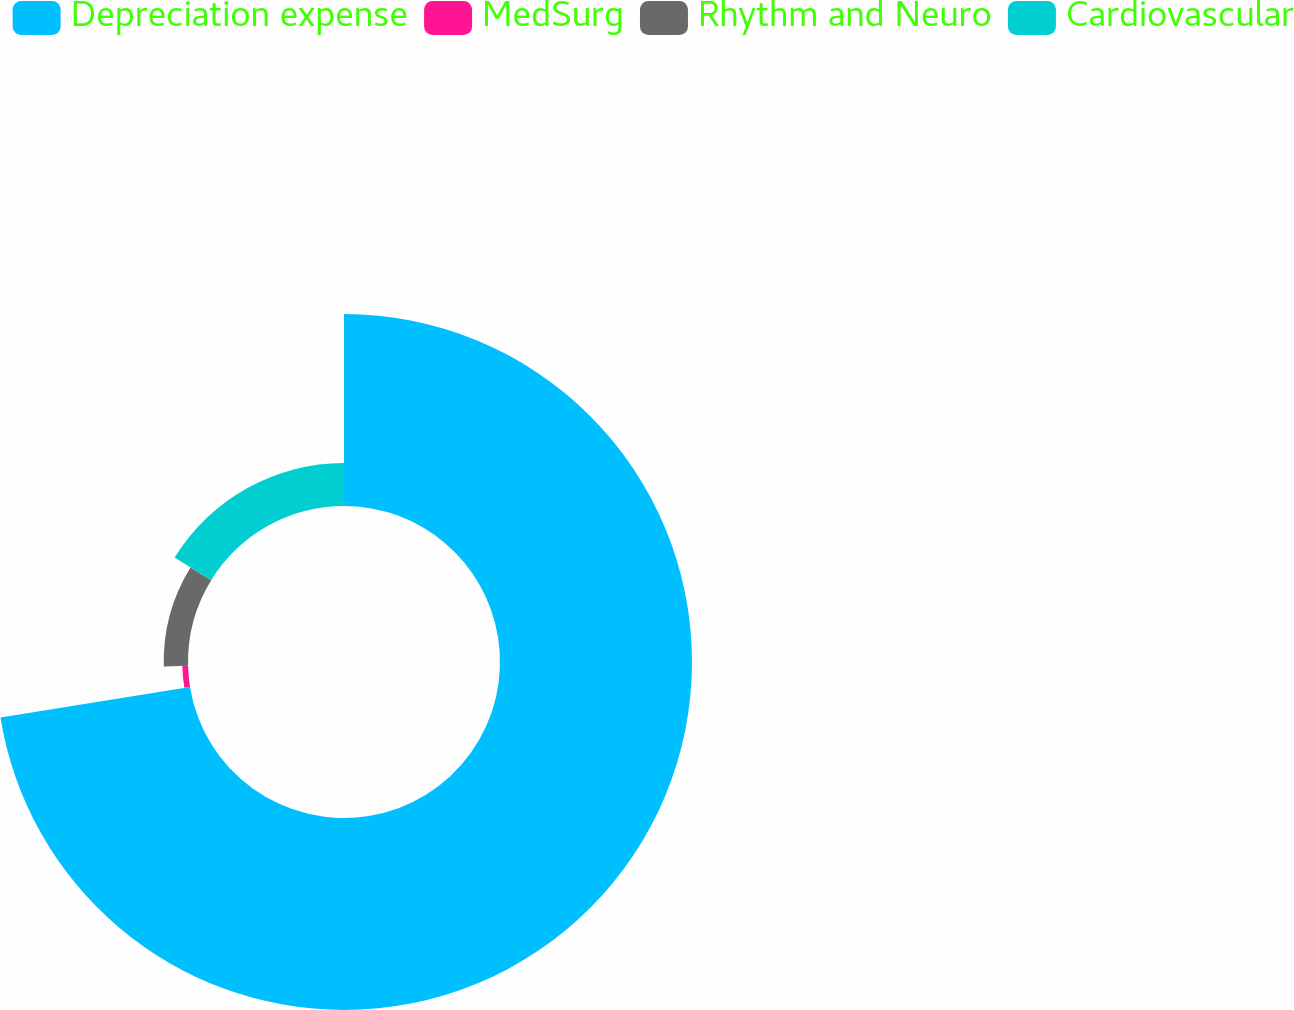Convert chart. <chart><loc_0><loc_0><loc_500><loc_500><pie_chart><fcel>Depreciation expense<fcel>MedSurg<fcel>Rhythm and Neuro<fcel>Cardiovascular<nl><fcel>72.45%<fcel>2.16%<fcel>9.18%<fcel>16.21%<nl></chart> 